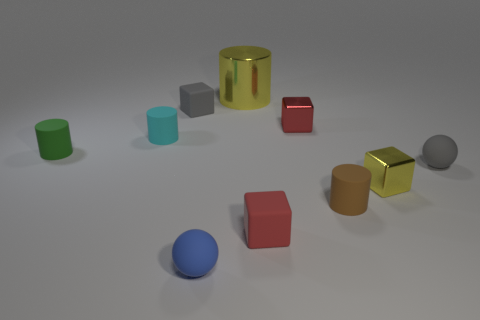Subtract 1 cubes. How many cubes are left? 3 Subtract all cylinders. How many objects are left? 6 Subtract 1 cyan cylinders. How many objects are left? 9 Subtract all cylinders. Subtract all cylinders. How many objects are left? 2 Add 9 small blue rubber balls. How many small blue rubber balls are left? 10 Add 6 gray matte balls. How many gray matte balls exist? 7 